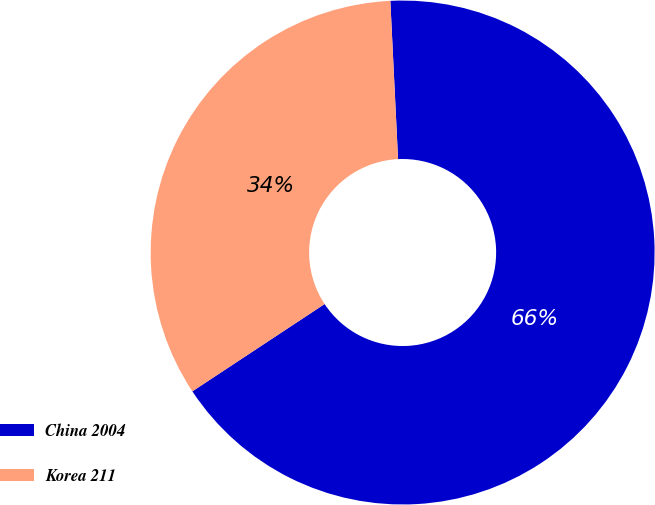Convert chart to OTSL. <chart><loc_0><loc_0><loc_500><loc_500><pie_chart><fcel>China 2004<fcel>Korea 211<nl><fcel>66.49%<fcel>33.51%<nl></chart> 